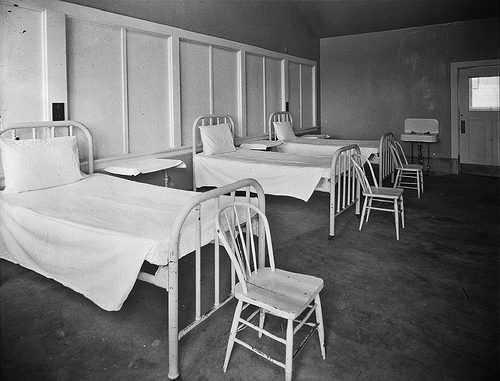This room looks like an old type of what?
A. church
B. hospital
C. prison
D. school The image depicts a room with beds and chairs that closely resembles an old-fashioned hospital ward, which is consistent with choice B. These types of rooms were common in medical facilities in the past, often characterized by their simplicity and minimalistic design. The absence of religious iconography, educational materials, or security measures that one might associate with churches, schools, or prisons, respectively, further supports the notion that this is indeed an image of an old hospital. 